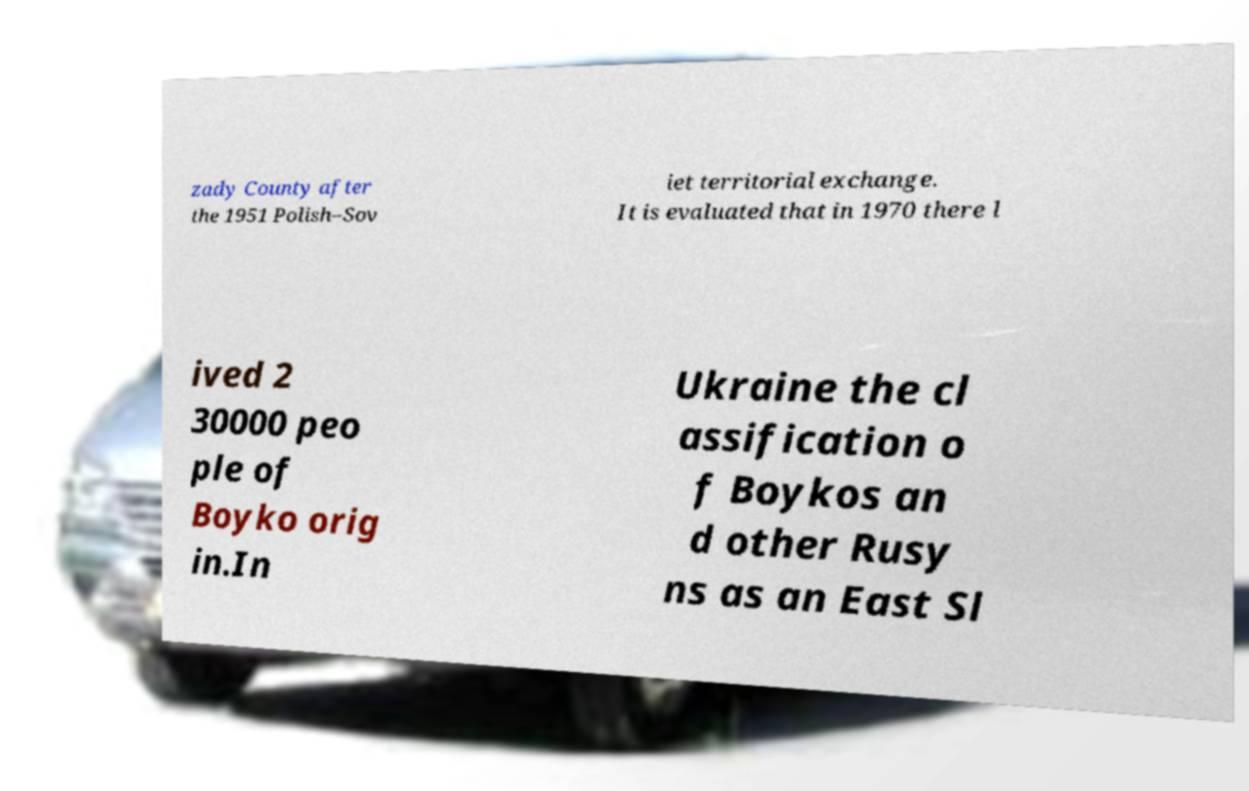Please identify and transcribe the text found in this image. zady County after the 1951 Polish–Sov iet territorial exchange. It is evaluated that in 1970 there l ived 2 30000 peo ple of Boyko orig in.In Ukraine the cl assification o f Boykos an d other Rusy ns as an East Sl 